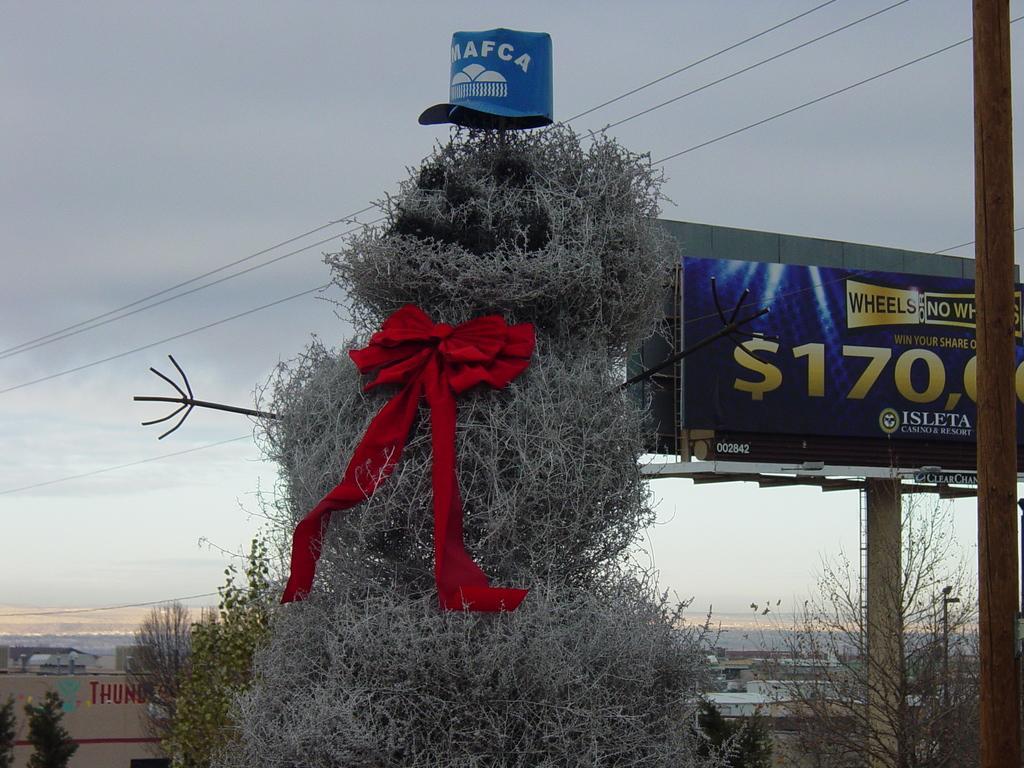Please provide a concise description of this image. In the middle of this image there is a plant which is looking like a snowman. In the middle of this plant a red color wreath is attached. At the top of the plant there is a blue color cap on which there is some text. At the bottom there are many trees and buildings. On the right side there are two poles and a board on which there is some text. At the top of the image I can see the sky. 